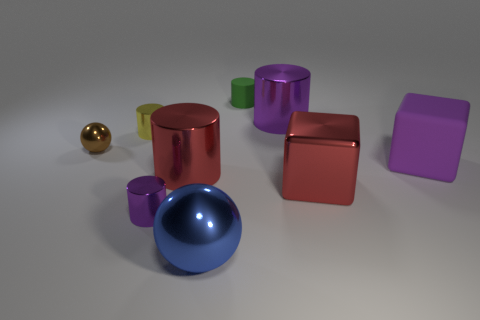How many green objects are large metallic blocks or large shiny spheres?
Your answer should be compact. 0. There is a cylinder behind the purple cylinder behind the large red shiny cube; what is its size?
Give a very brief answer. Small. There is a large purple thing that is the same shape as the tiny yellow shiny thing; what is it made of?
Keep it short and to the point. Metal. What number of red things have the same size as the brown object?
Offer a very short reply. 0. Do the red shiny cube and the blue metallic thing have the same size?
Your answer should be very brief. Yes. What is the size of the object that is on the right side of the large blue shiny thing and on the left side of the big purple metallic cylinder?
Your answer should be very brief. Small. Are there more purple metal things left of the big red metallic cylinder than small yellow metallic cylinders that are in front of the big metallic cube?
Give a very brief answer. Yes. What color is the other object that is the same shape as the purple matte object?
Make the answer very short. Red. Does the large metal cylinder in front of the big purple matte thing have the same color as the tiny rubber cylinder?
Keep it short and to the point. No. What number of big metal cubes are there?
Your answer should be very brief. 1. 